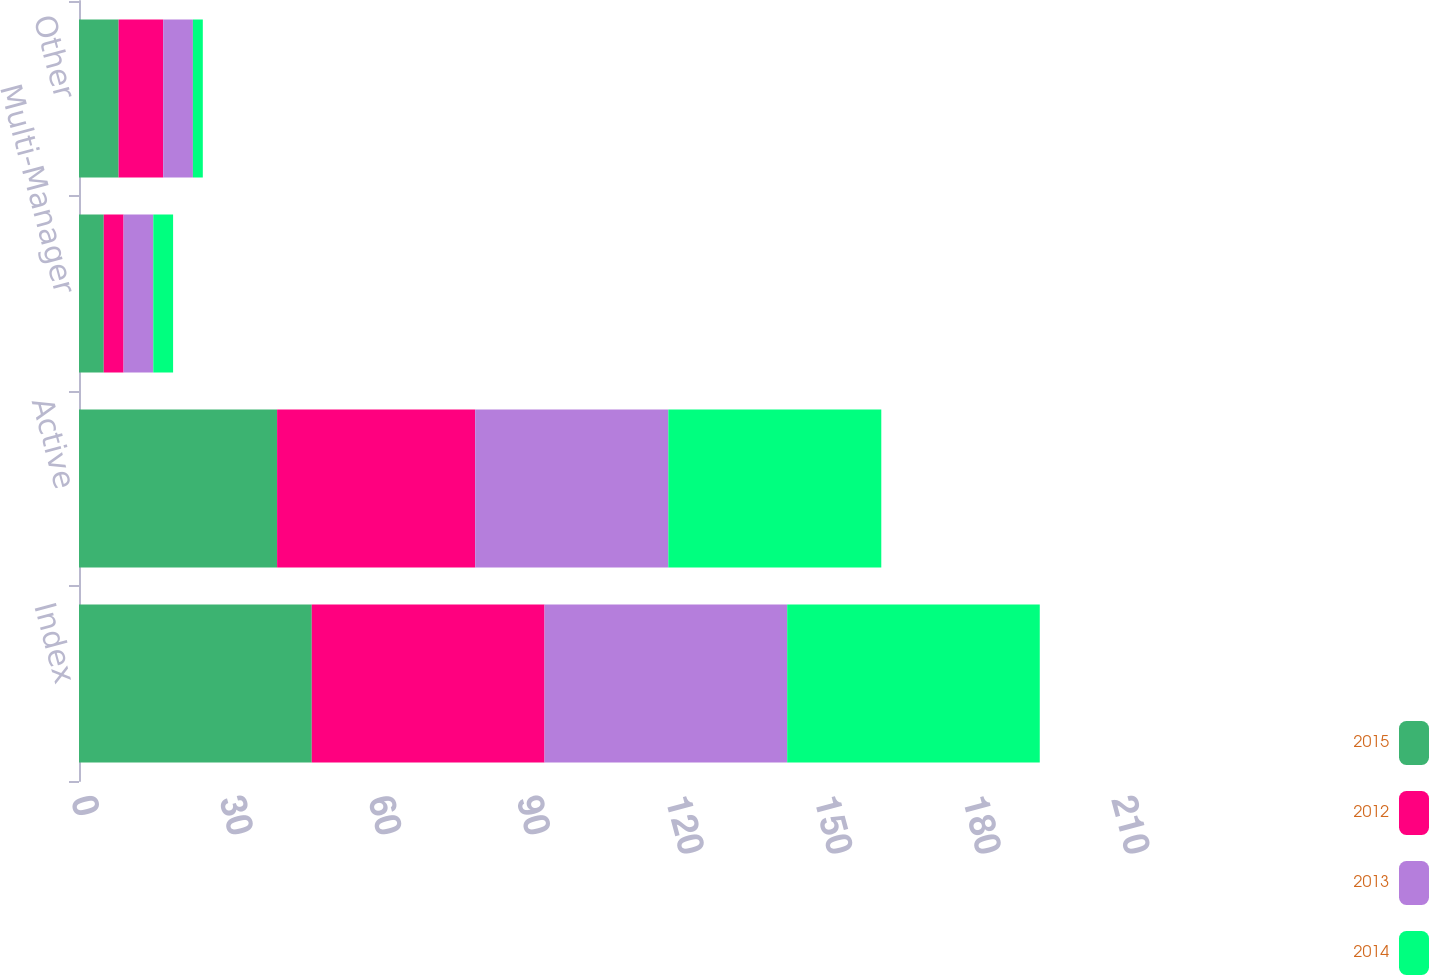<chart> <loc_0><loc_0><loc_500><loc_500><stacked_bar_chart><ecel><fcel>Index<fcel>Active<fcel>Multi-Manager<fcel>Other<nl><fcel>2015<fcel>47<fcel>40<fcel>5<fcel>8<nl><fcel>2012<fcel>47<fcel>40<fcel>4<fcel>9<nl><fcel>2013<fcel>49<fcel>39<fcel>6<fcel>6<nl><fcel>2014<fcel>51<fcel>43<fcel>4<fcel>2<nl></chart> 